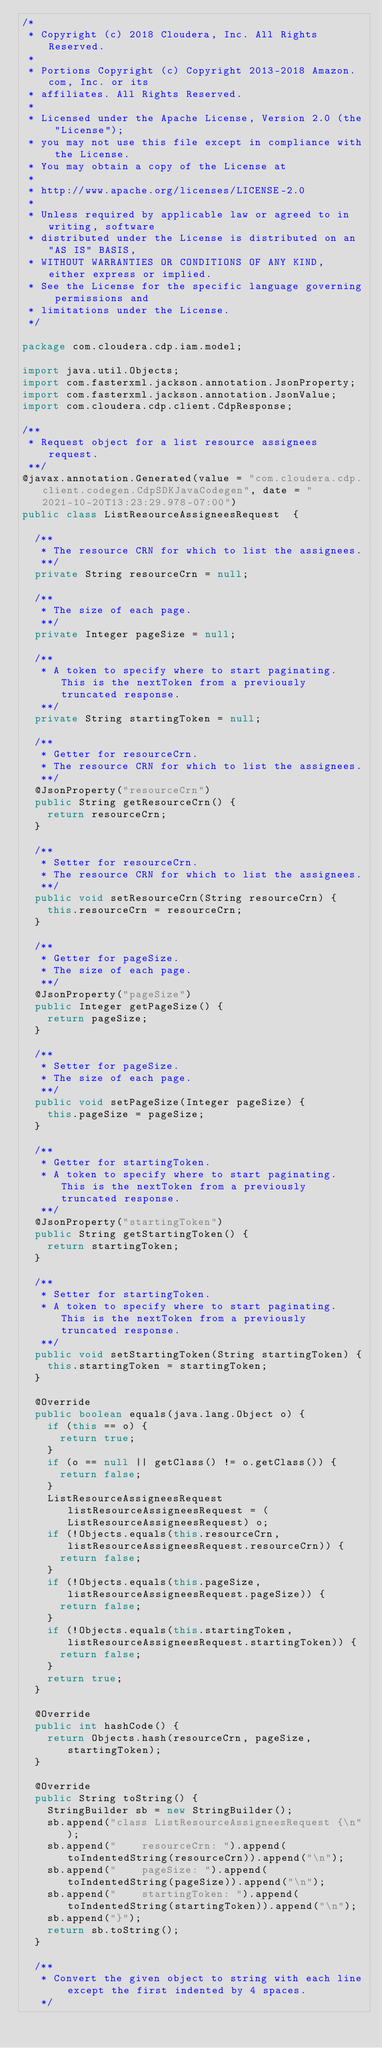Convert code to text. <code><loc_0><loc_0><loc_500><loc_500><_Java_>/*
 * Copyright (c) 2018 Cloudera, Inc. All Rights Reserved.
 *
 * Portions Copyright (c) Copyright 2013-2018 Amazon.com, Inc. or its
 * affiliates. All Rights Reserved.
 *
 * Licensed under the Apache License, Version 2.0 (the "License");
 * you may not use this file except in compliance with the License.
 * You may obtain a copy of the License at
 *
 * http://www.apache.org/licenses/LICENSE-2.0
 *
 * Unless required by applicable law or agreed to in writing, software
 * distributed under the License is distributed on an "AS IS" BASIS,
 * WITHOUT WARRANTIES OR CONDITIONS OF ANY KIND, either express or implied.
 * See the License for the specific language governing permissions and
 * limitations under the License.
 */

package com.cloudera.cdp.iam.model;

import java.util.Objects;
import com.fasterxml.jackson.annotation.JsonProperty;
import com.fasterxml.jackson.annotation.JsonValue;
import com.cloudera.cdp.client.CdpResponse;

/**
 * Request object for a list resource assignees request.
 **/
@javax.annotation.Generated(value = "com.cloudera.cdp.client.codegen.CdpSDKJavaCodegen", date = "2021-10-20T13:23:29.978-07:00")
public class ListResourceAssigneesRequest  {

  /**
   * The resource CRN for which to list the assignees.
   **/
  private String resourceCrn = null;

  /**
   * The size of each page.
   **/
  private Integer pageSize = null;

  /**
   * A token to specify where to start paginating. This is the nextToken from a previously truncated response.
   **/
  private String startingToken = null;

  /**
   * Getter for resourceCrn.
   * The resource CRN for which to list the assignees.
   **/
  @JsonProperty("resourceCrn")
  public String getResourceCrn() {
    return resourceCrn;
  }

  /**
   * Setter for resourceCrn.
   * The resource CRN for which to list the assignees.
   **/
  public void setResourceCrn(String resourceCrn) {
    this.resourceCrn = resourceCrn;
  }

  /**
   * Getter for pageSize.
   * The size of each page.
   **/
  @JsonProperty("pageSize")
  public Integer getPageSize() {
    return pageSize;
  }

  /**
   * Setter for pageSize.
   * The size of each page.
   **/
  public void setPageSize(Integer pageSize) {
    this.pageSize = pageSize;
  }

  /**
   * Getter for startingToken.
   * A token to specify where to start paginating. This is the nextToken from a previously truncated response.
   **/
  @JsonProperty("startingToken")
  public String getStartingToken() {
    return startingToken;
  }

  /**
   * Setter for startingToken.
   * A token to specify where to start paginating. This is the nextToken from a previously truncated response.
   **/
  public void setStartingToken(String startingToken) {
    this.startingToken = startingToken;
  }

  @Override
  public boolean equals(java.lang.Object o) {
    if (this == o) {
      return true;
    }
    if (o == null || getClass() != o.getClass()) {
      return false;
    }
    ListResourceAssigneesRequest listResourceAssigneesRequest = (ListResourceAssigneesRequest) o;
    if (!Objects.equals(this.resourceCrn, listResourceAssigneesRequest.resourceCrn)) {
      return false;
    }
    if (!Objects.equals(this.pageSize, listResourceAssigneesRequest.pageSize)) {
      return false;
    }
    if (!Objects.equals(this.startingToken, listResourceAssigneesRequest.startingToken)) {
      return false;
    }
    return true;
  }

  @Override
  public int hashCode() {
    return Objects.hash(resourceCrn, pageSize, startingToken);
  }

  @Override
  public String toString() {
    StringBuilder sb = new StringBuilder();
    sb.append("class ListResourceAssigneesRequest {\n");
    sb.append("    resourceCrn: ").append(toIndentedString(resourceCrn)).append("\n");
    sb.append("    pageSize: ").append(toIndentedString(pageSize)).append("\n");
    sb.append("    startingToken: ").append(toIndentedString(startingToken)).append("\n");
    sb.append("}");
    return sb.toString();
  }

  /**
   * Convert the given object to string with each line except the first indented by 4 spaces.
   */</code> 